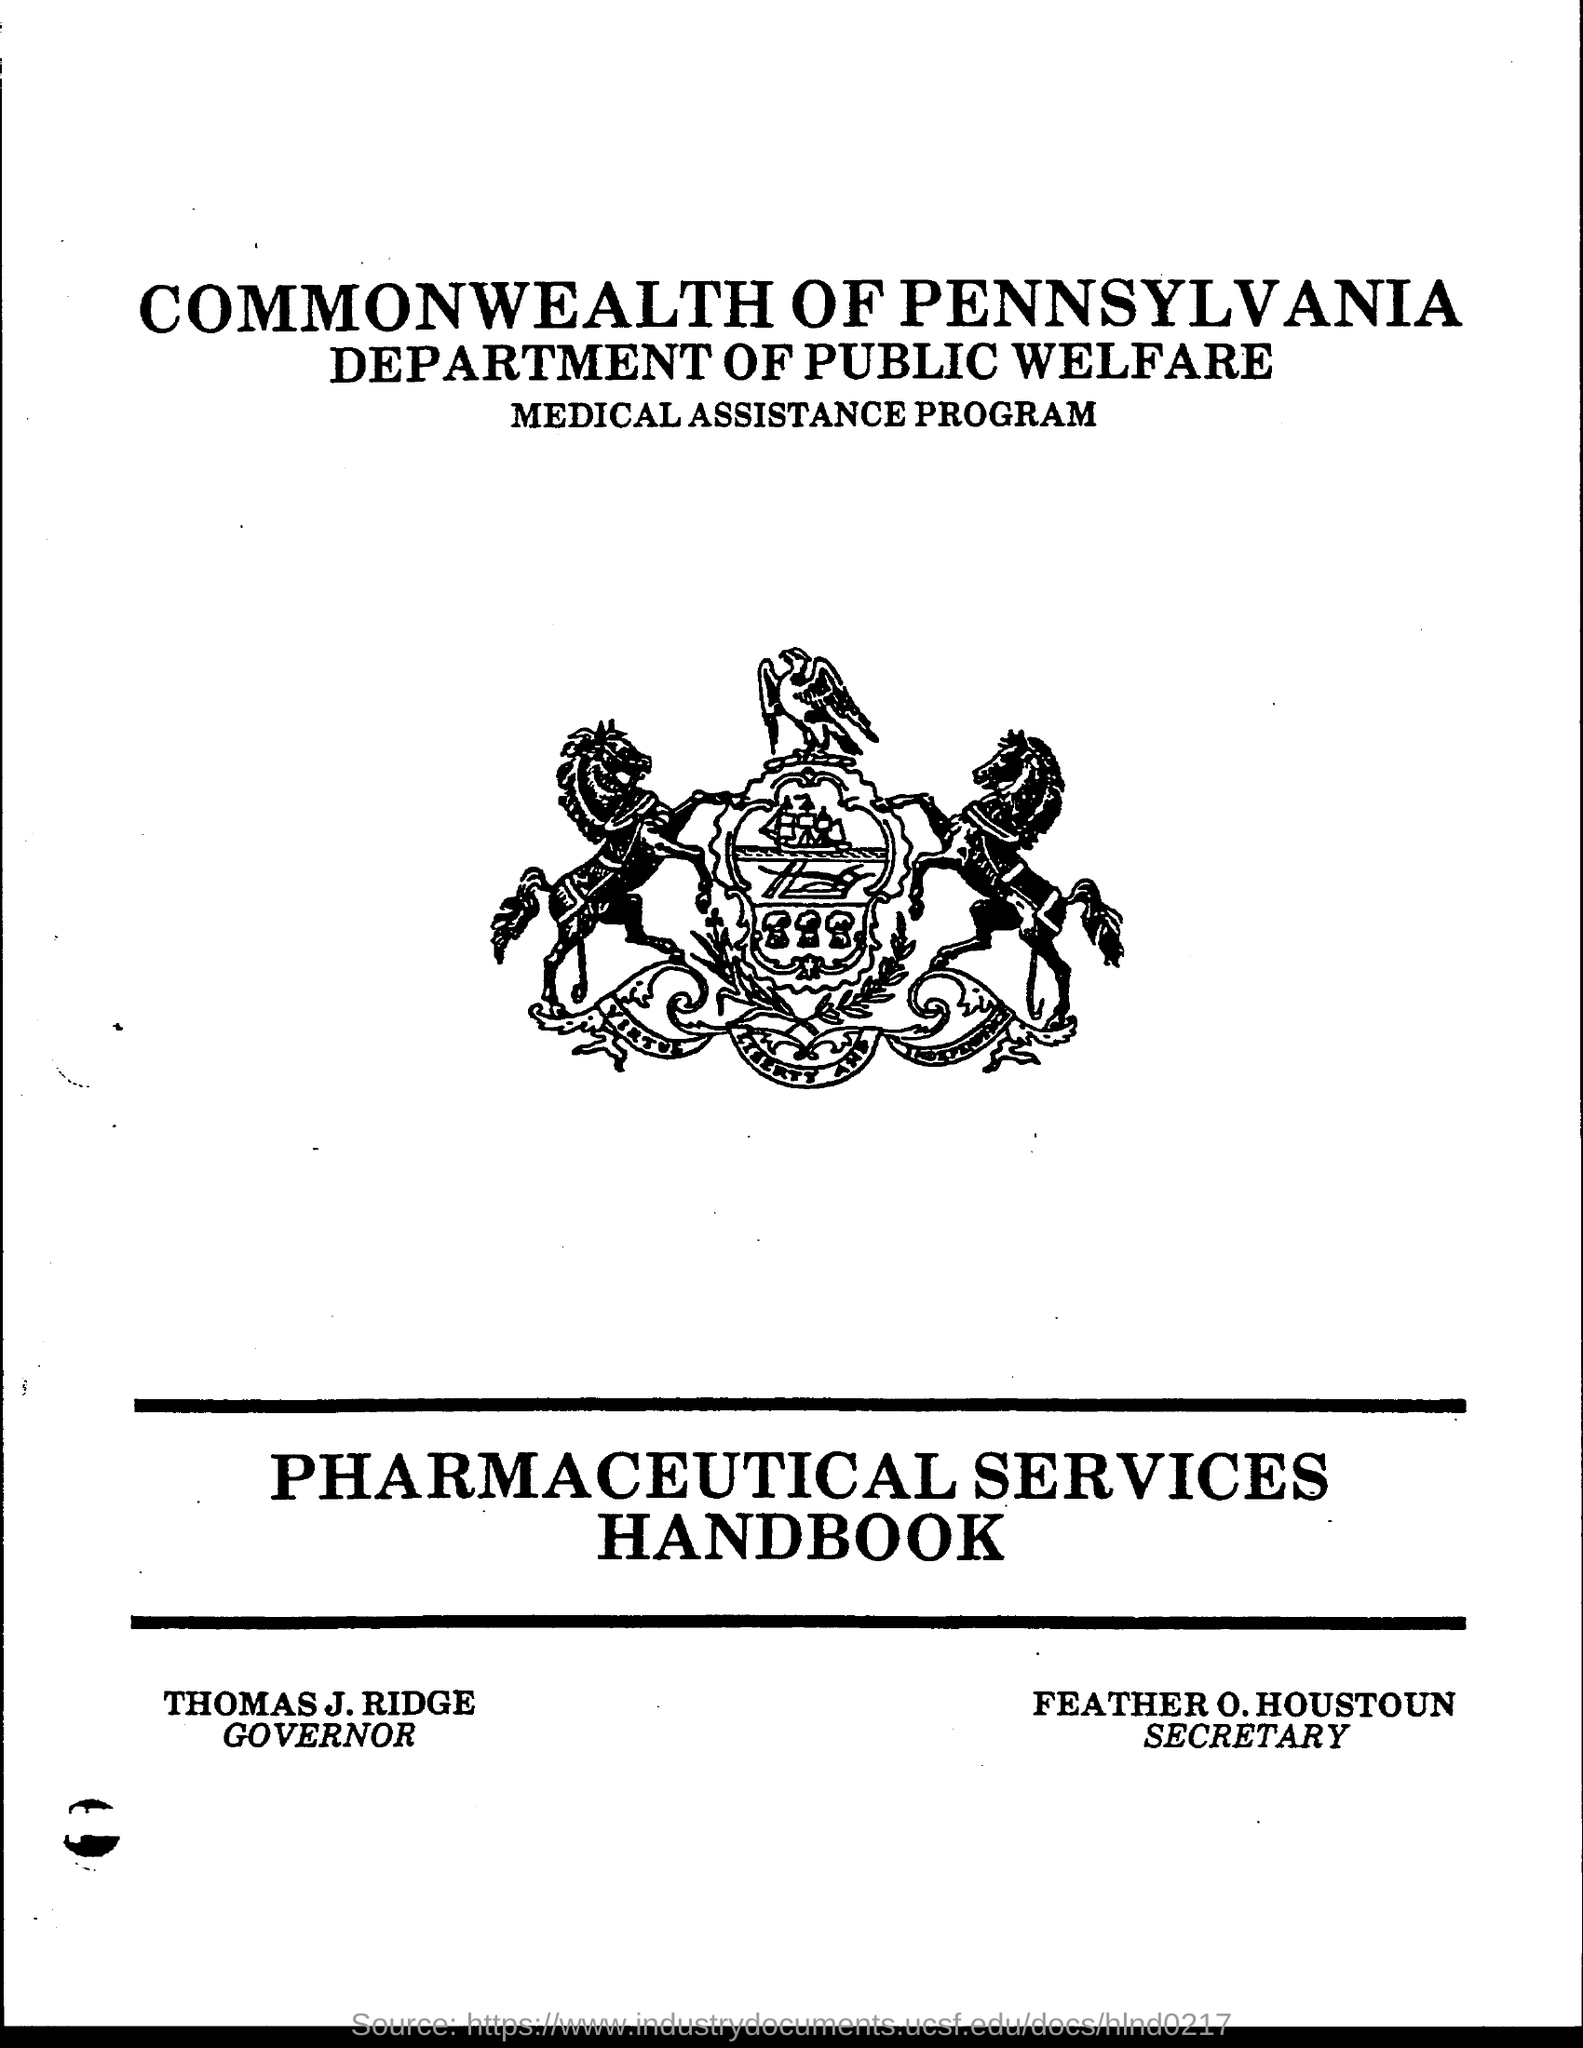What is the position of thomas j. ridge ?
Offer a very short reply. Governor. What is the position of feather o. houston ?
Keep it short and to the point. SECRETARY. 